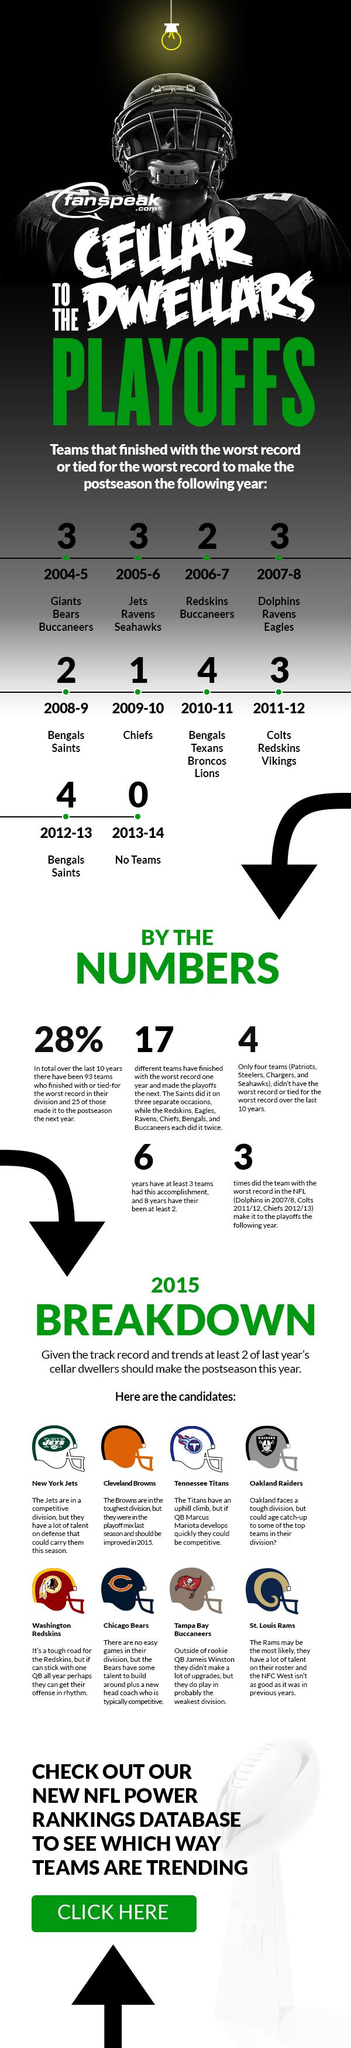Specify some key components in this picture. In the 2005-2006 season, the New York Jets, Baltimore Ravens, and Seattle Seahawks finished with the worst or tied for the worst records in the league. The helmet of the Washington Redskins is red. Of the years in which NFL teams had the worst record, three instances occurred in which the same team made it to the playoffs the following season: 2007/2008, 2011/2012, and 2012/2013. Seventeen different teams have finished a season with the worst record. The seasons of 2008-2009 and 2012-2013 were the worst record for the New Orleans Saints. 